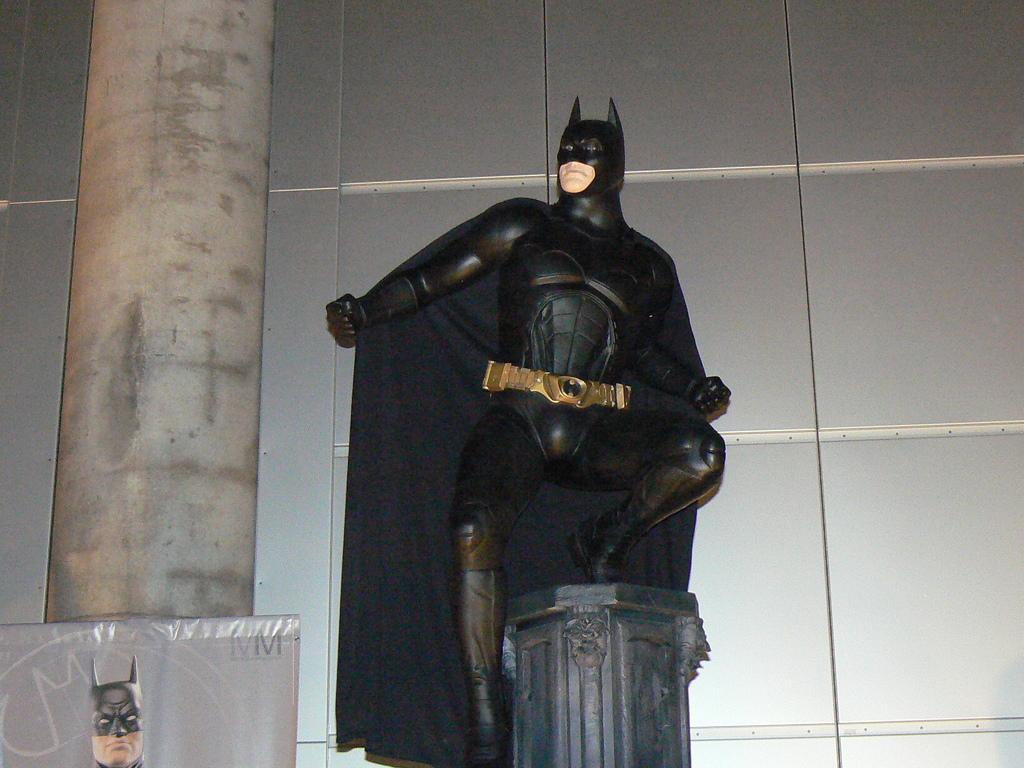In one or two sentences, can you explain what this image depicts? In this image we can see a statue on the pillar, there is a board to another pillar and wall in the background. 